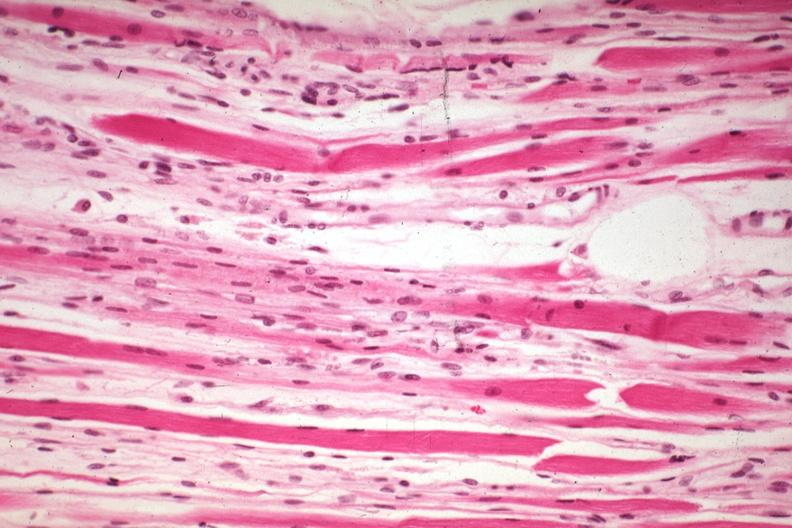what is present?
Answer the question using a single word or phrase. Muscle 